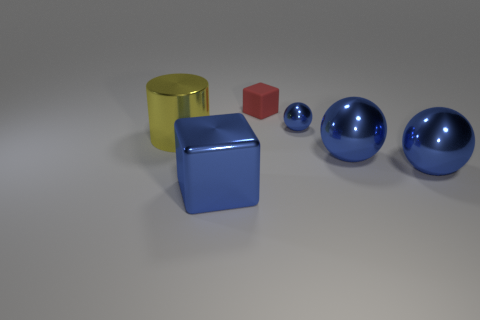The other shiny object that is the same size as the red thing is what shape?
Offer a terse response. Sphere. Are there any tiny purple rubber objects that have the same shape as the large yellow object?
Offer a terse response. No. There is a tiny thing on the left side of the tiny blue thing; is its color the same as the block to the left of the tiny red rubber cube?
Your response must be concise. No. Are there any tiny red rubber things in front of the yellow cylinder?
Provide a succinct answer. No. There is a large thing that is both on the left side of the tiny shiny sphere and in front of the yellow metal cylinder; what is it made of?
Make the answer very short. Metal. Is the material of the thing that is behind the small blue metallic object the same as the big blue block?
Make the answer very short. No. What is the material of the blue block?
Offer a very short reply. Metal. How big is the cube that is in front of the tiny red rubber block?
Give a very brief answer. Large. Are there any other things that have the same color as the small matte block?
Keep it short and to the point. No. There is a tiny object to the right of the red rubber thing on the left side of the tiny sphere; are there any big blue shiny cubes left of it?
Provide a short and direct response. Yes. 